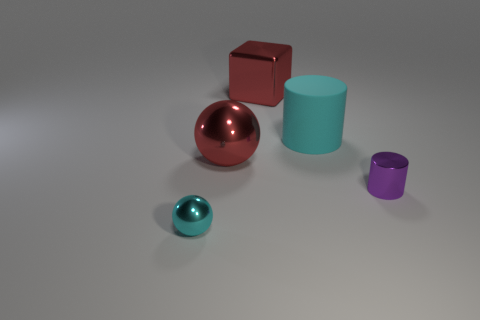Add 5 purple shiny cylinders. How many objects exist? 10 Subtract all cylinders. How many objects are left? 3 Subtract all big rubber cylinders. Subtract all red blocks. How many objects are left? 3 Add 3 tiny purple cylinders. How many tiny purple cylinders are left? 4 Add 5 small things. How many small things exist? 7 Subtract 1 cyan cylinders. How many objects are left? 4 